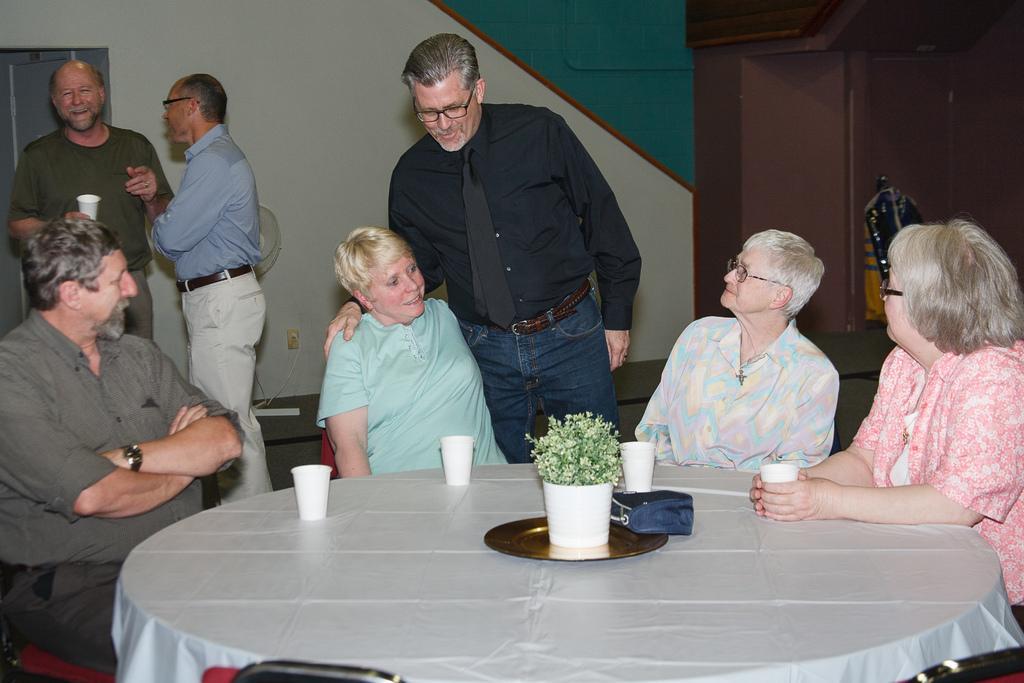In one or two sentences, can you explain what this image depicts? As we can see in the image, there are four people sitting on chairs around table. On table there are glasses and a plant and there are three persons standing and there is a white color wall over here. 